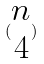Convert formula to latex. <formula><loc_0><loc_0><loc_500><loc_500>( \begin{matrix} n \\ 4 \end{matrix} )</formula> 